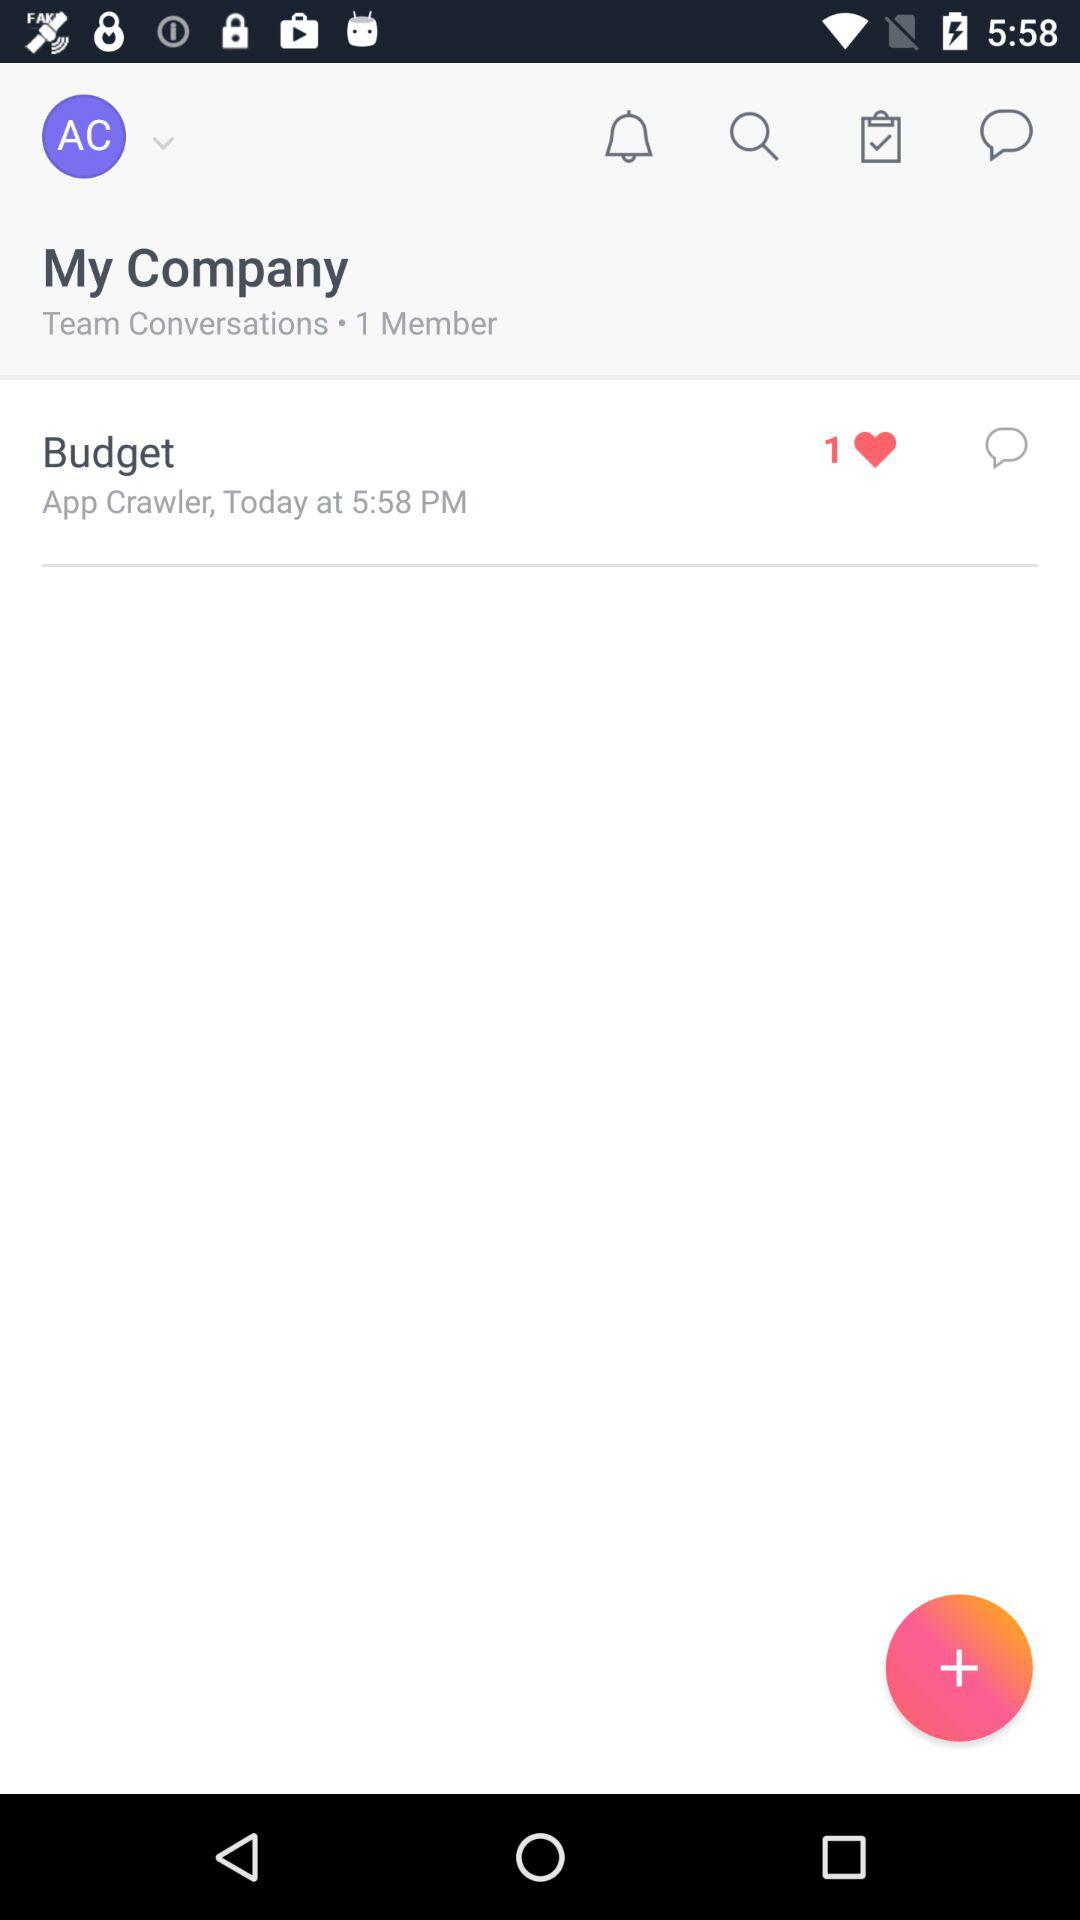What is the given time? The given time is 5:58 p.m. 